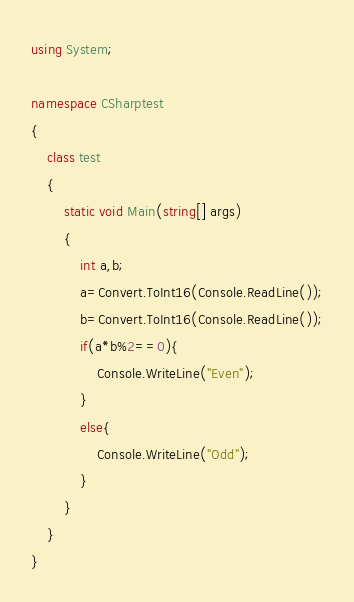<code> <loc_0><loc_0><loc_500><loc_500><_C#_>using System;

namespace CSharptest
{
    class test
    {
        static void Main(string[] args)
        {
            int a,b;
            a=Convert.ToInt16(Console.ReadLine());
            b=Convert.ToInt16(Console.ReadLine());
            if(a*b%2==0){
                Console.WriteLine("Even");
            }
            else{
                Console.WriteLine("Odd");
            }
        }
    }
}</code> 